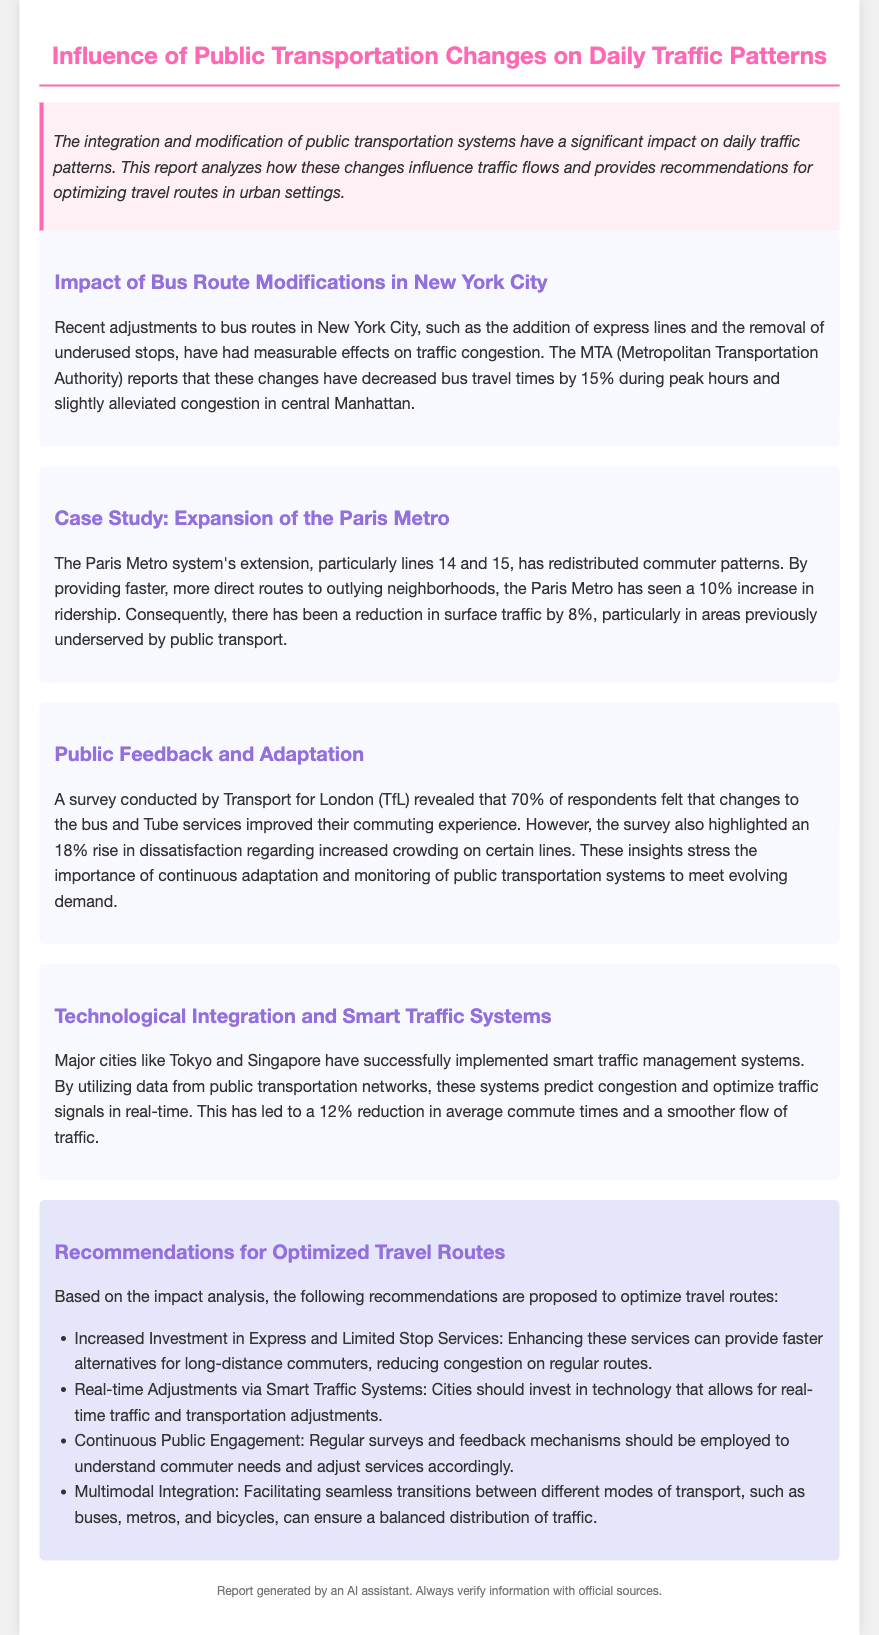What percentage decrease in bus travel times was reported during peak hours? The document states that bus travel times decreased by 15% during peak hours due to route modifications.
Answer: 15% What was the increase in ridership after the expansion of the Paris Metro? The report mentions a 10% increase in ridership resulting from the Metro extension.
Answer: 10% Which organization conducted a survey regarding public transport satisfaction? The survey about commuter experiences was conducted by Transport for London (TfL).
Answer: Transport for London What percentage of respondents felt the changes to services improved their commuting experience? According to the survey results, 70% of respondents felt the service changes improved their commuting experience.
Answer: 70% What is one suggested improvement for travel routes according to the recommendations? One recommendation is to increase investment in express and limited stop services to provide faster alternatives for commuters.
Answer: Increased Investment in Express and Limited Stop Services What technology is suggested for real-time traffic and transportation adjustments? The document suggests investing in smart traffic systems to allow for real-time adjustments.
Answer: Smart Traffic Systems What was the reduction in surface traffic attributed to the Paris Metro expansion? The report indicates an 8% reduction in surface traffic, which is linked to the Metro system's extension.
Answer: 8% What is the primary focus of the report? The primary focus of the report is to analyze the impact of public transportation changes on daily traffic patterns.
Answer: Public Transportation Changes What strategy is recommended for understanding commuter needs? The report recommends employing regular surveys and feedback mechanisms for continuous public engagement to understand commuter needs.
Answer: Continuous Public Engagement 